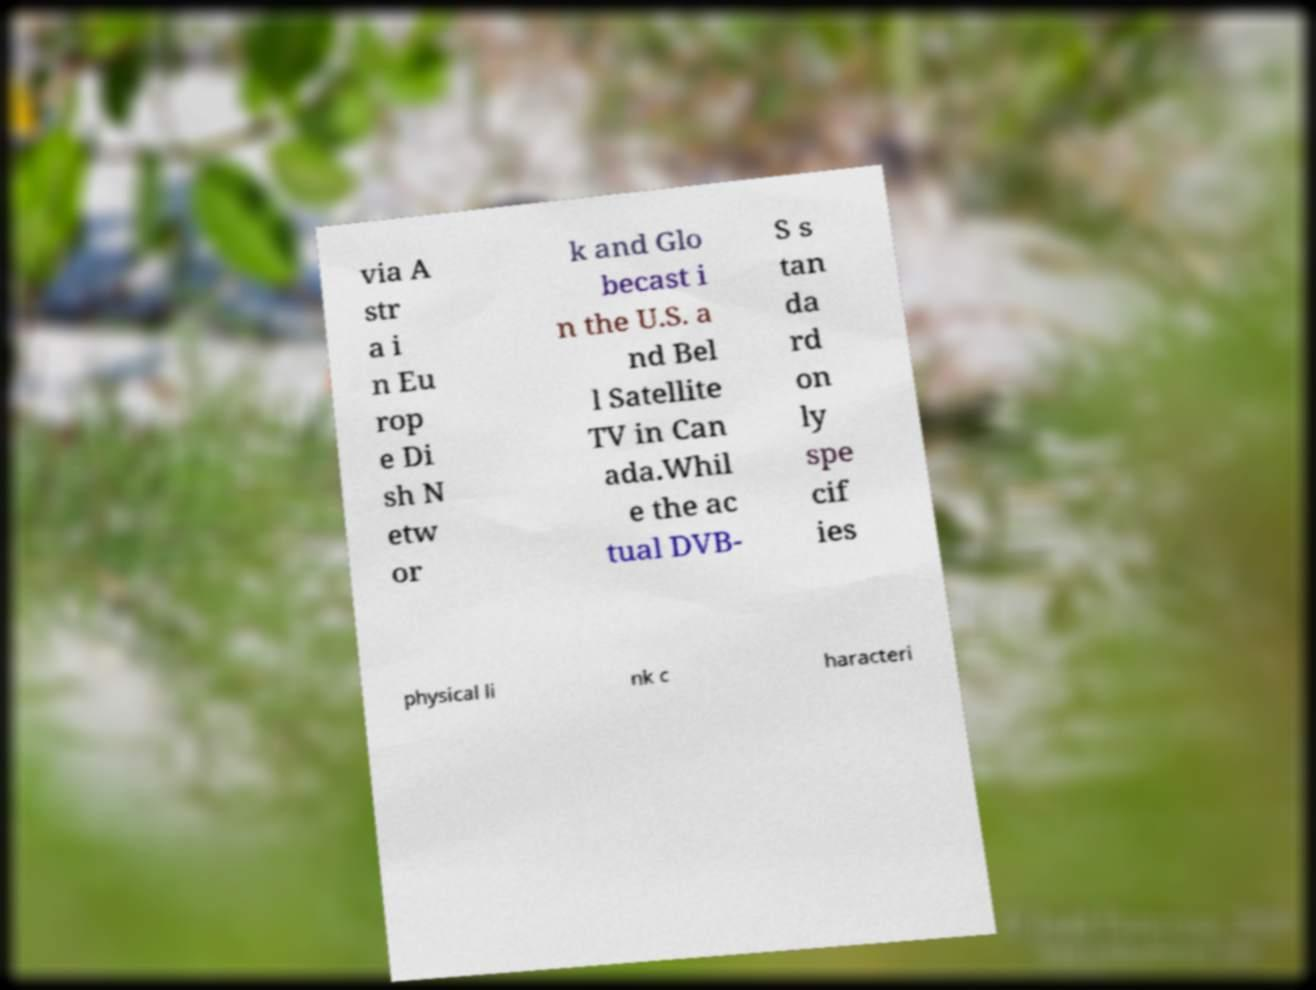What messages or text are displayed in this image? I need them in a readable, typed format. via A str a i n Eu rop e Di sh N etw or k and Glo becast i n the U.S. a nd Bel l Satellite TV in Can ada.Whil e the ac tual DVB- S s tan da rd on ly spe cif ies physical li nk c haracteri 